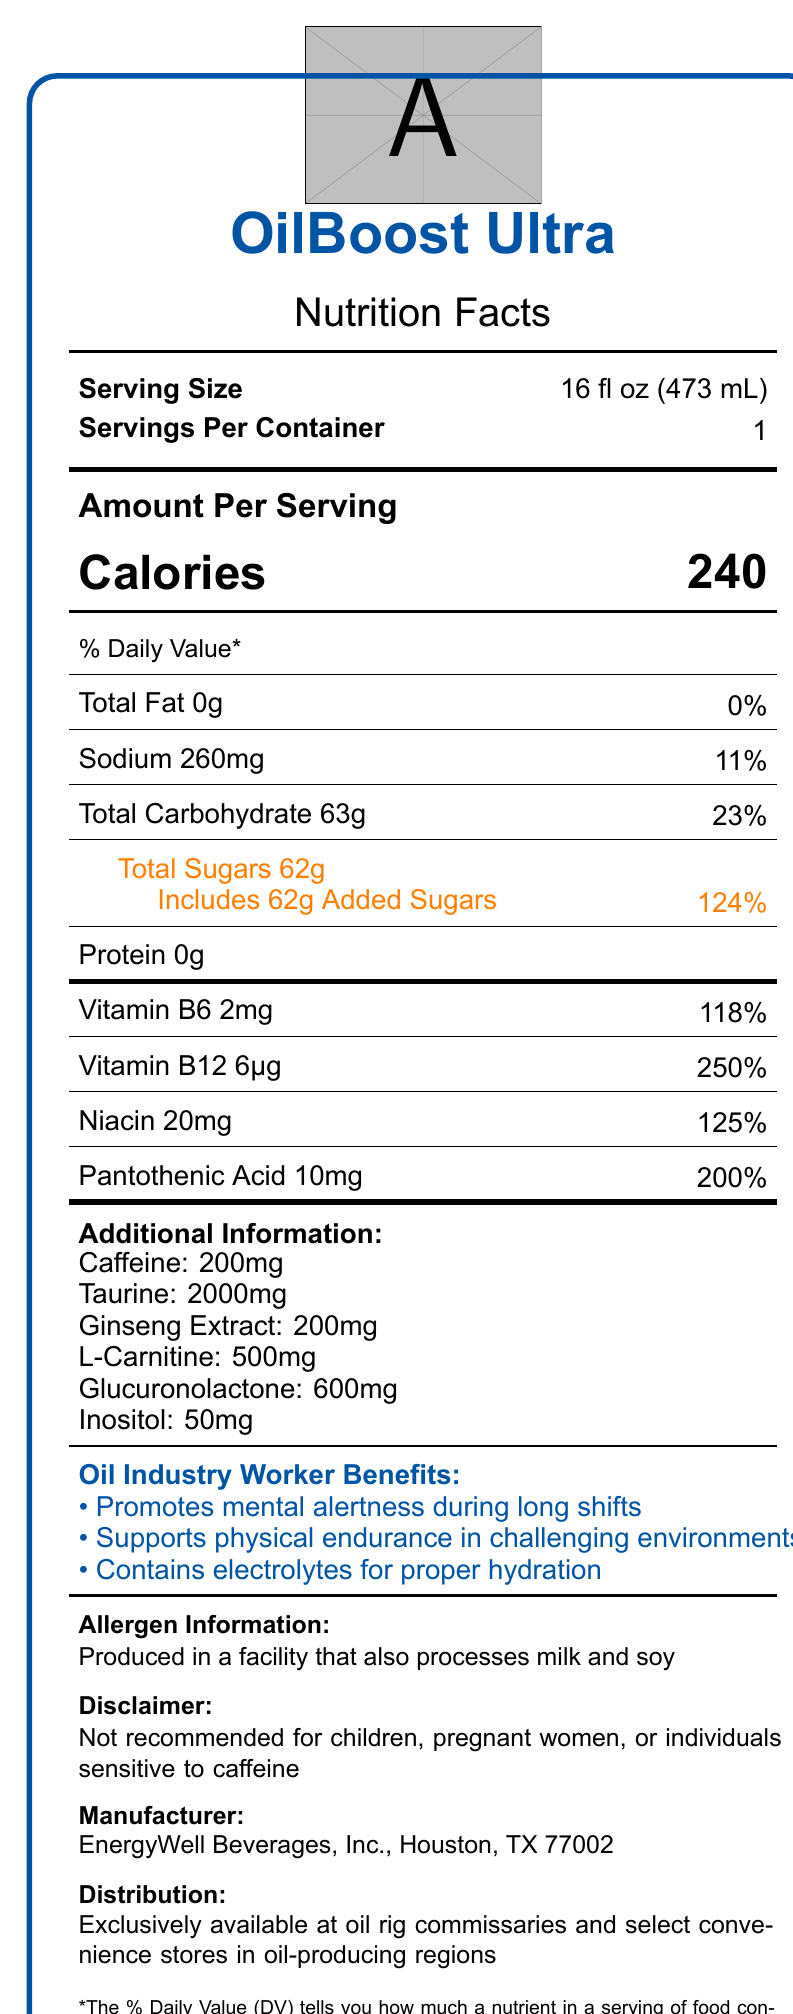How many calories are in one serving of OilBoost Ultra? The document lists "Calories" as 240 in bold letters within the Amount Per Serving section.
Answer: 240 What is the serving size for OilBoost Ultra? The document states "Serving Size" as 16 fl oz (473 mL) near the top of the label.
Answer: 16 fl oz (473 mL) How much sodium is in a serving of OilBoost Ultra? The document lists "Sodium 260mg" under the % Daily Value section.
Answer: 260mg What percentage of the daily value of vitamin B12 does one serving of OilBoost Ultra provide? The document shows "Vitamin B12 6μg" with a daily value percentage of "250%" in the vitamins and minerals section.
Answer: 250% What are the total carbohydrates in a serving of OilBoost Ultra? The document mentions "Total Carbohydrate 63g" in the % Daily Value section, along with its daily value percentage.
Answer: 63g Which statement is true about the sugars in OilBoost Ultra? A. It contains 50g of total sugars. B. It contains 10g of added sugars. C. It contains 62g of total sugars with 62g added sugars. D. It contains 0g of sugars. The document states "Total Sugars 62g" and "Includes 62g Added Sugars" in orange text within the % Daily Value section.
Answer: C Which of the following ingredients is found in the highest amount in OilBoost Ultra? 1. Ginseng Extract 2. L-Carnitine 3. Taurine 4. Inositol The document lists Taurine as 2000mg, which is higher than the amounts listed for Ginseng Extract (200mg), L-Carnitine (500mg), and Inositol (50mg).
Answer: 3. Taurine Is OilBoost Ultra recommended for children? The document has a disclaimer stating, "Not recommended for children, pregnant women, or individuals sensitive to caffeine."
Answer: No Summarize the nutritional characteristics and special features of OilBoost Ultra. This summary gathers information from multiple sections of the document, including the nutrition facts, additional ingredients, marketing claims, and distribution details.
Answer: OilBoost Ultra is a premium energy drink with 240 calories per serving. It contains 0g of fat, 260mg of sodium, 63g of carbohydrates, and 62g of sugars, all of which are added. It lacks protein and is fortified with numerous vitamins including Vitamin B6, B12, Niacin, and Pantothenic Acid. Additionally, it contains performance-enhancing ingredients such as caffeine, taurine, ginseng extract, L-carnitine, glucuronolactone, and inositol. Specially formulated for oil industry workers, it promotes mental alertness, physical endurance, and proper hydration. It contains allergen information and is distributed exclusively at specific locations. Who manufactures OilBoost Ultra? The manufacturer information at the bottom of the document states "EnergyWell Beverages, Inc., Houston, TX 77002."
Answer: EnergyWell Beverages, Inc., Houston, TX 77002 What is the total percentage of daily value for all vitamins and minerals listed in the document? The document specifies percentages for each vitamin and mineral individually but does not provide a total cumulative percentage.
Answer: Cannot be determined 